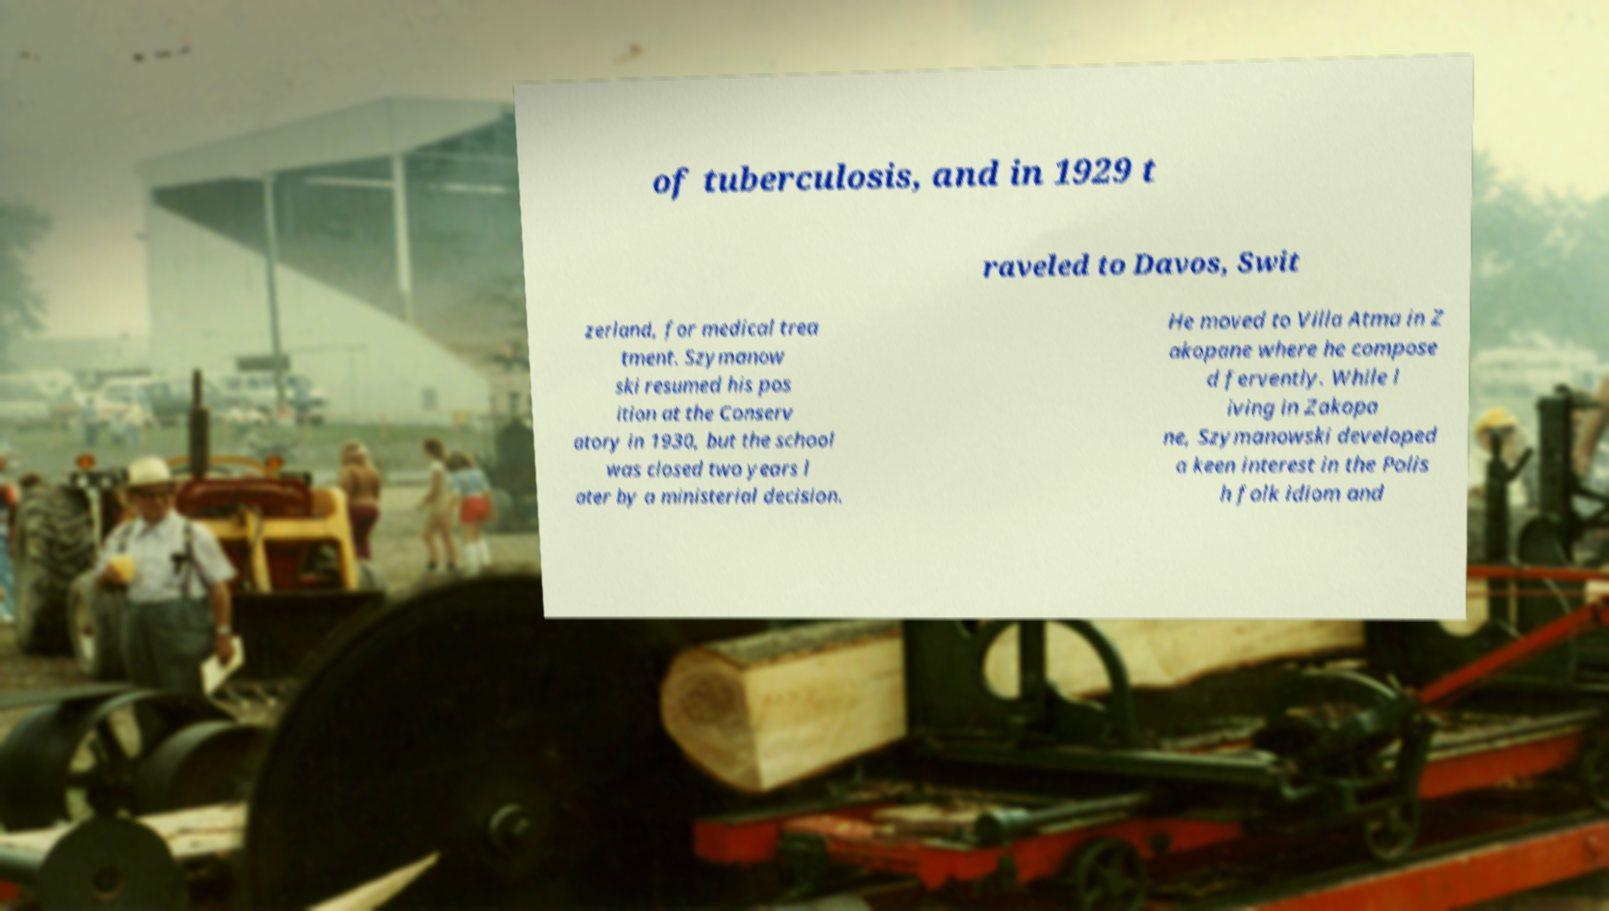What messages or text are displayed in this image? I need them in a readable, typed format. of tuberculosis, and in 1929 t raveled to Davos, Swit zerland, for medical trea tment. Szymanow ski resumed his pos ition at the Conserv atory in 1930, but the school was closed two years l ater by a ministerial decision. He moved to Villa Atma in Z akopane where he compose d fervently. While l iving in Zakopa ne, Szymanowski developed a keen interest in the Polis h folk idiom and 